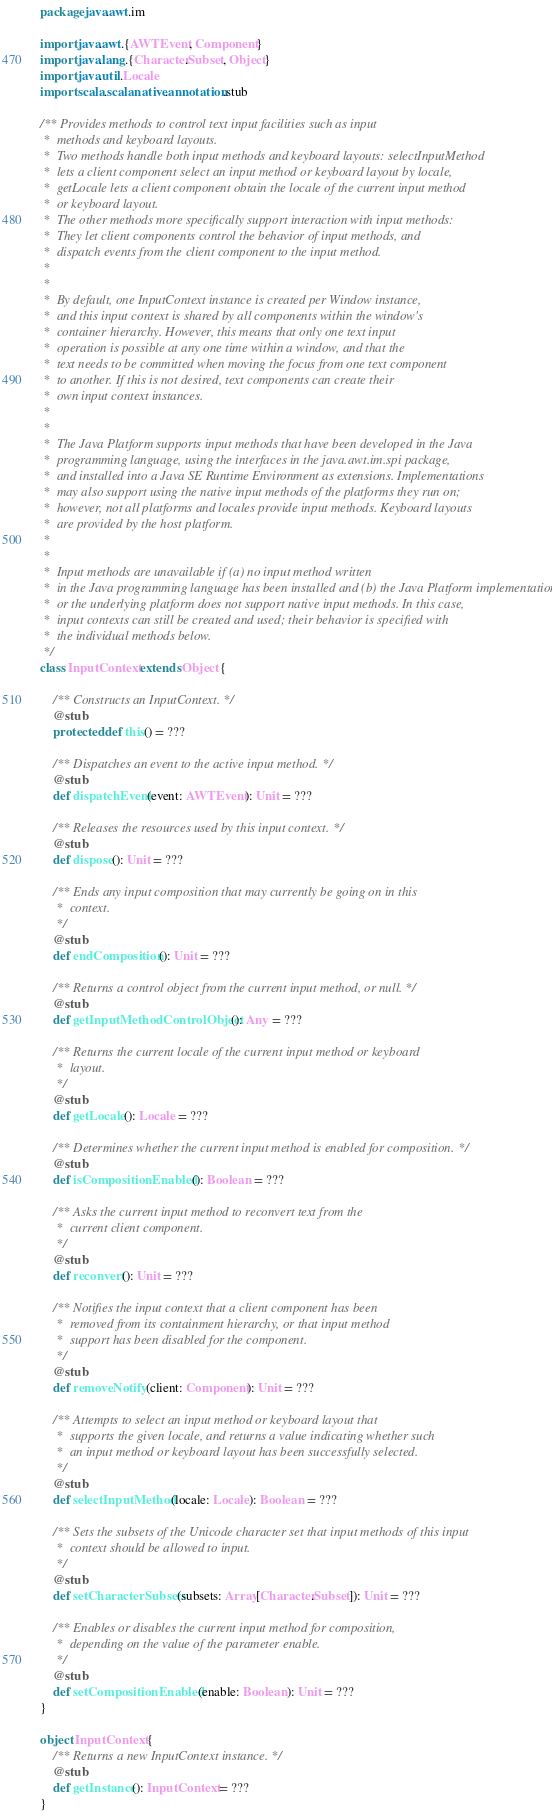Convert code to text. <code><loc_0><loc_0><loc_500><loc_500><_Scala_>package java.awt.im

import java.awt.{AWTEvent, Component}
import java.lang.{Character.Subset, Object}
import java.util.Locale
import scala.scalanative.annotation.stub

/** Provides methods to control text input facilities such as input
 *  methods and keyboard layouts.
 *  Two methods handle both input methods and keyboard layouts: selectInputMethod
 *  lets a client component select an input method or keyboard layout by locale,
 *  getLocale lets a client component obtain the locale of the current input method
 *  or keyboard layout.
 *  The other methods more specifically support interaction with input methods:
 *  They let client components control the behavior of input methods, and
 *  dispatch events from the client component to the input method.
 * 
 *  
 *  By default, one InputContext instance is created per Window instance,
 *  and this input context is shared by all components within the window's
 *  container hierarchy. However, this means that only one text input
 *  operation is possible at any one time within a window, and that the
 *  text needs to be committed when moving the focus from one text component
 *  to another. If this is not desired, text components can create their
 *  own input context instances.
 * 
 *  
 *  The Java Platform supports input methods that have been developed in the Java
 *  programming language, using the interfaces in the java.awt.im.spi package,
 *  and installed into a Java SE Runtime Environment as extensions. Implementations
 *  may also support using the native input methods of the platforms they run on;
 *  however, not all platforms and locales provide input methods. Keyboard layouts
 *  are provided by the host platform.
 * 
 *  
 *  Input methods are unavailable if (a) no input method written
 *  in the Java programming language has been installed and (b) the Java Platform implementation
 *  or the underlying platform does not support native input methods. In this case,
 *  input contexts can still be created and used; their behavior is specified with
 *  the individual methods below.
 */
class InputContext extends Object {

    /** Constructs an InputContext. */
    @stub
    protected def this() = ???

    /** Dispatches an event to the active input method. */
    @stub
    def dispatchEvent(event: AWTEvent): Unit = ???

    /** Releases the resources used by this input context. */
    @stub
    def dispose(): Unit = ???

    /** Ends any input composition that may currently be going on in this
     *  context.
     */
    @stub
    def endComposition(): Unit = ???

    /** Returns a control object from the current input method, or null. */
    @stub
    def getInputMethodControlObject(): Any = ???

    /** Returns the current locale of the current input method or keyboard
     *  layout.
     */
    @stub
    def getLocale(): Locale = ???

    /** Determines whether the current input method is enabled for composition. */
    @stub
    def isCompositionEnabled(): Boolean = ???

    /** Asks the current input method to reconvert text from the
     *  current client component.
     */
    @stub
    def reconvert(): Unit = ???

    /** Notifies the input context that a client component has been
     *  removed from its containment hierarchy, or that input method
     *  support has been disabled for the component.
     */
    @stub
    def removeNotify(client: Component): Unit = ???

    /** Attempts to select an input method or keyboard layout that
     *  supports the given locale, and returns a value indicating whether such
     *  an input method or keyboard layout has been successfully selected.
     */
    @stub
    def selectInputMethod(locale: Locale): Boolean = ???

    /** Sets the subsets of the Unicode character set that input methods of this input
     *  context should be allowed to input.
     */
    @stub
    def setCharacterSubsets(subsets: Array[Character.Subset]): Unit = ???

    /** Enables or disables the current input method for composition,
     *  depending on the value of the parameter enable.
     */
    @stub
    def setCompositionEnabled(enable: Boolean): Unit = ???
}

object InputContext {
    /** Returns a new InputContext instance. */
    @stub
    def getInstance(): InputContext = ???
}
</code> 